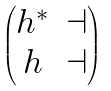Convert formula to latex. <formula><loc_0><loc_0><loc_500><loc_500>\begin{pmatrix} h ^ { * } & \dashv \\ h & \dashv \end{pmatrix}</formula> 